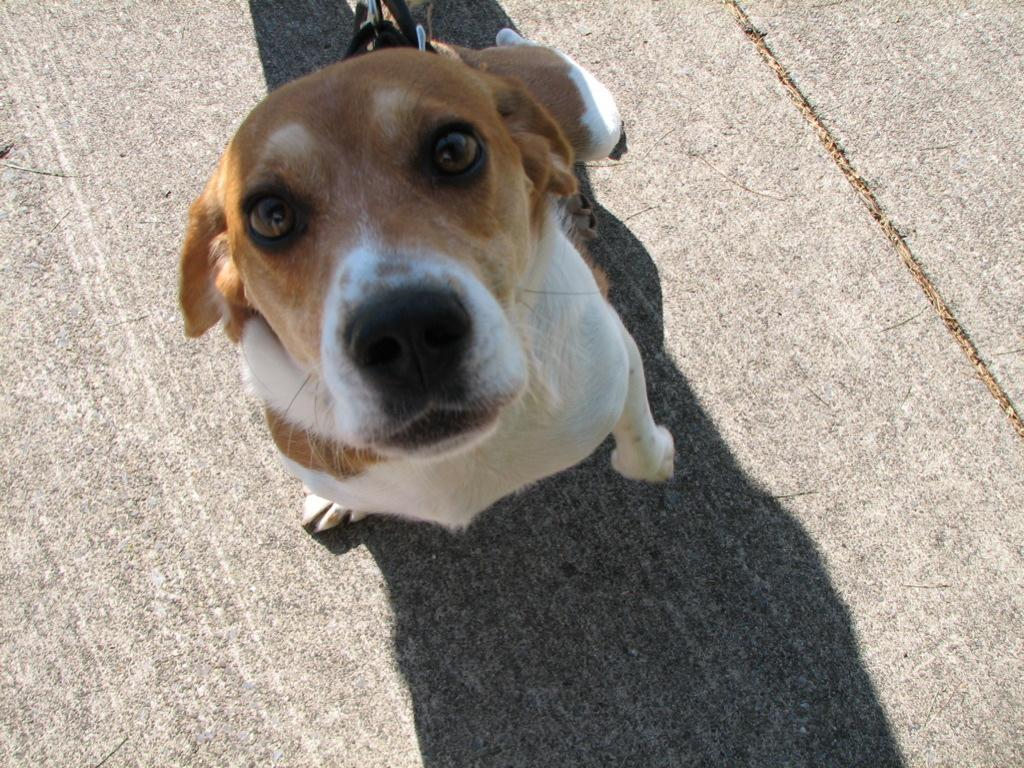What type of animal is in the image? There is a dog in the image. What is around the dog's neck? The dog has a belt around its neck. What colors can be seen on the dog? The dog is white and brown in color. What type of jam is the dog eating in the image? There is no jam present in the image; the dog is not eating anything. 